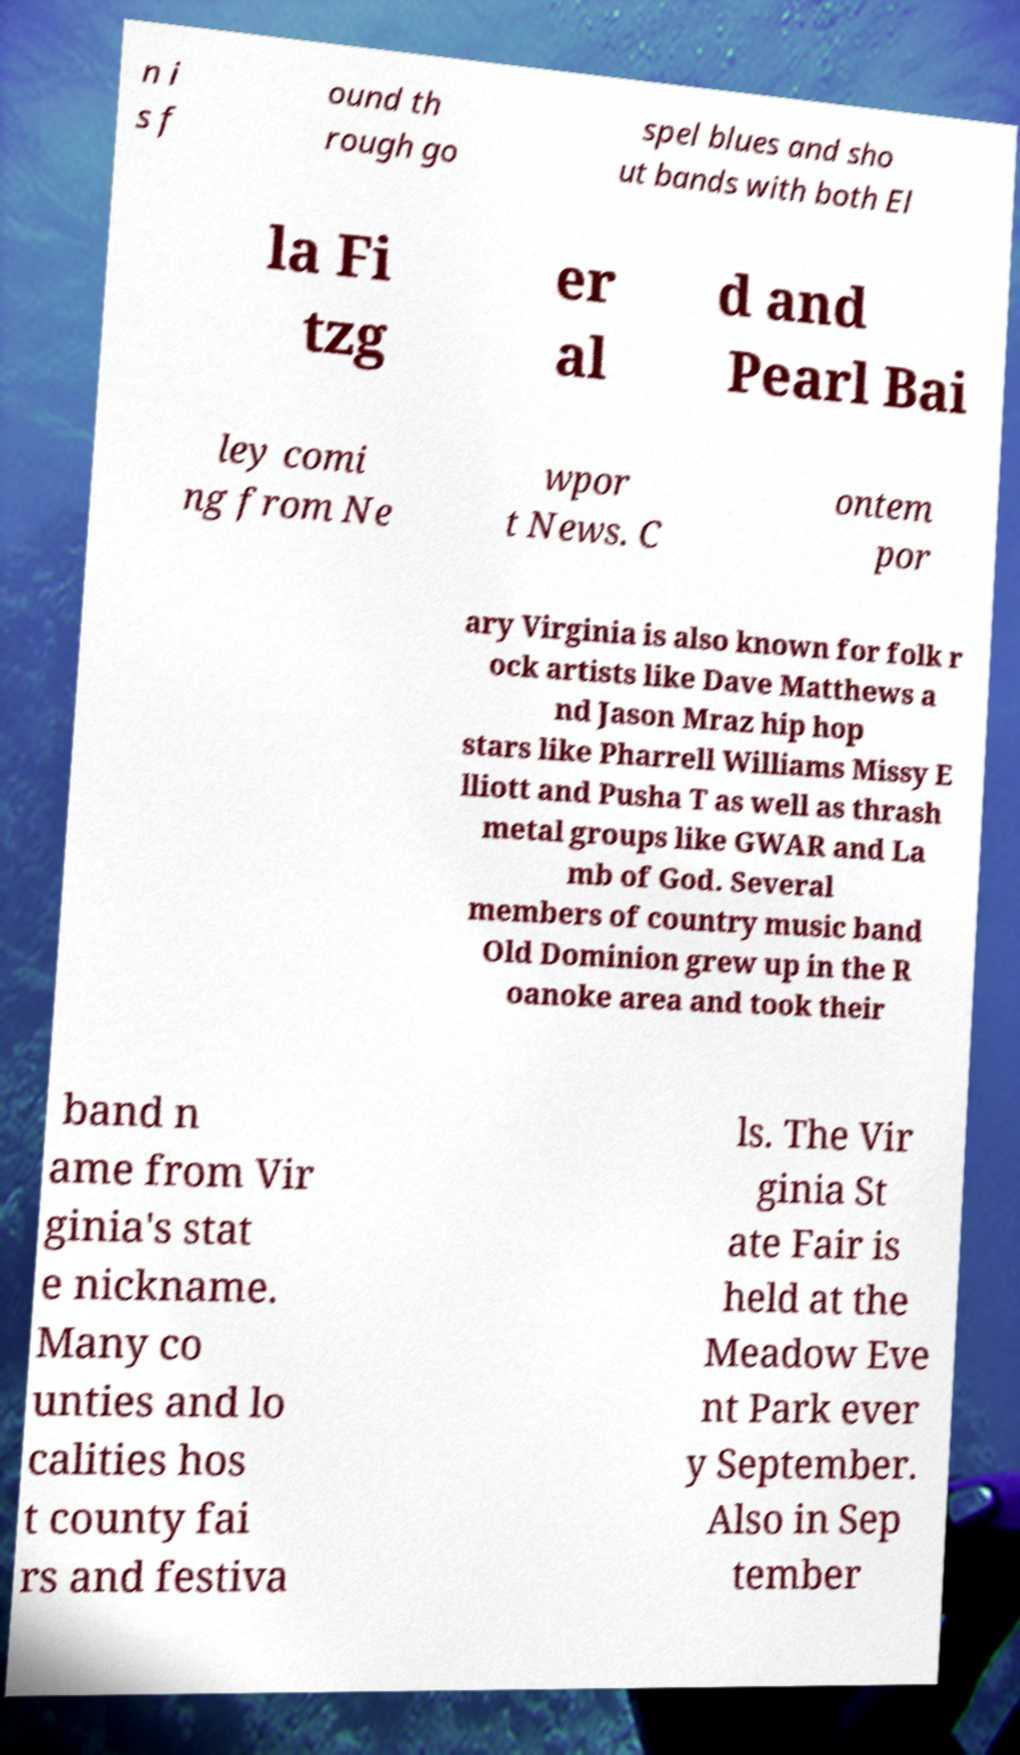What messages or text are displayed in this image? I need them in a readable, typed format. n i s f ound th rough go spel blues and sho ut bands with both El la Fi tzg er al d and Pearl Bai ley comi ng from Ne wpor t News. C ontem por ary Virginia is also known for folk r ock artists like Dave Matthews a nd Jason Mraz hip hop stars like Pharrell Williams Missy E lliott and Pusha T as well as thrash metal groups like GWAR and La mb of God. Several members of country music band Old Dominion grew up in the R oanoke area and took their band n ame from Vir ginia's stat e nickname. Many co unties and lo calities hos t county fai rs and festiva ls. The Vir ginia St ate Fair is held at the Meadow Eve nt Park ever y September. Also in Sep tember 